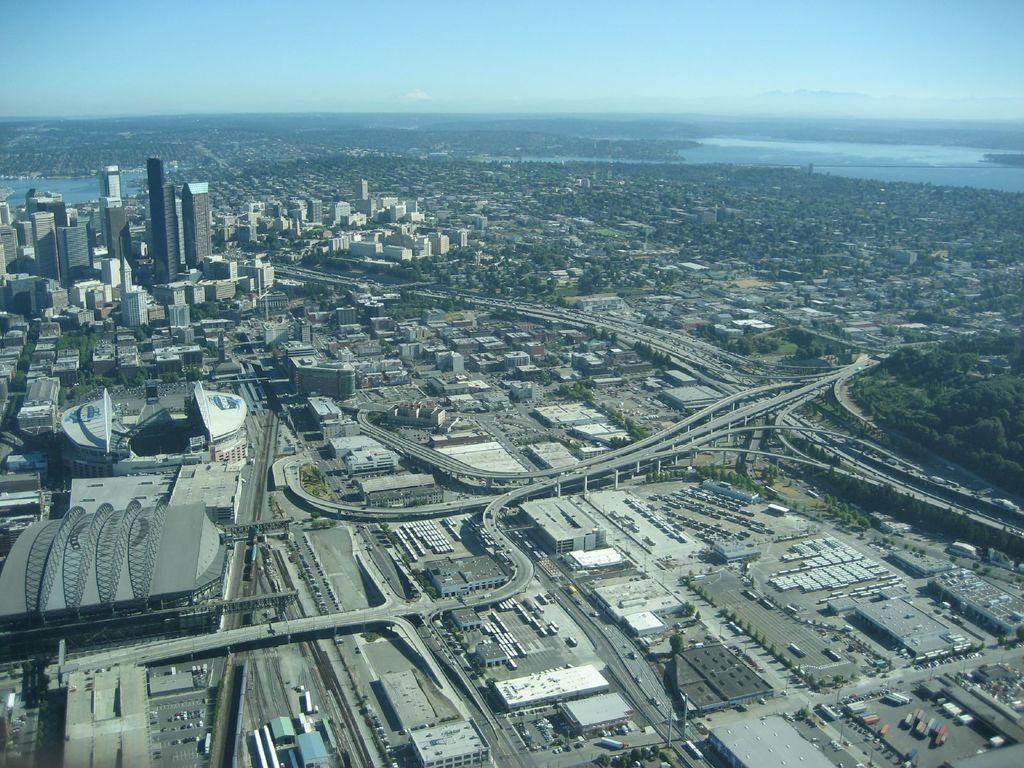What type of structures can be seen in the image? There are buildings in the image. What natural elements are present in the image? There are trees in the image. Can you describe any other objects visible in the image? There are other objects in the image, but their specific details are not mentioned in the provided facts. What is visible in the background of the image? The sky is visible in the image. What color is the silver moon in the image? There is no moon present in the image, and therefore no silver moon can be observed. 